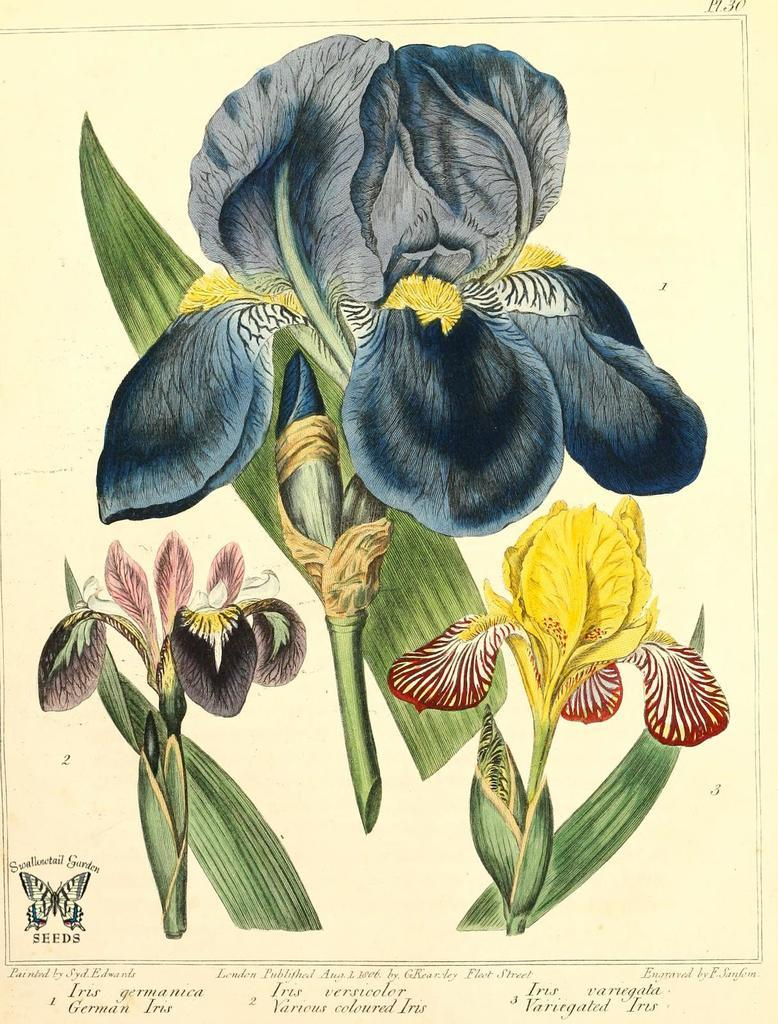What is the main subject of the image? The main subject of the image is a sheet. What is depicted on the sheet? The sheet has paintings of three plants and a butterfly. Are there any words or texts on the sheet? Yes, there are texts on the sheet. What is the color of the sheet's background? The background of the sheet is cream in color. Can you tell me how the manager is using the pocket in the image? There is no manager or pocket present in the image; it features a sheet with paintings of plants and a butterfly. 